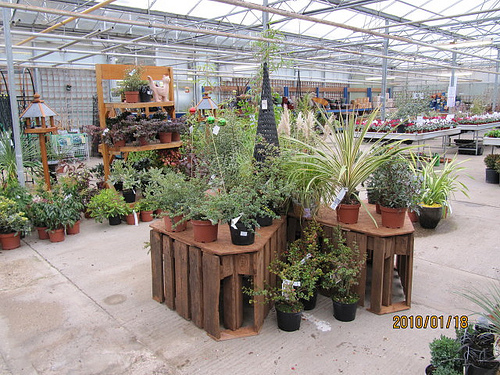Identify the text contained in this image. 2010/01/18 